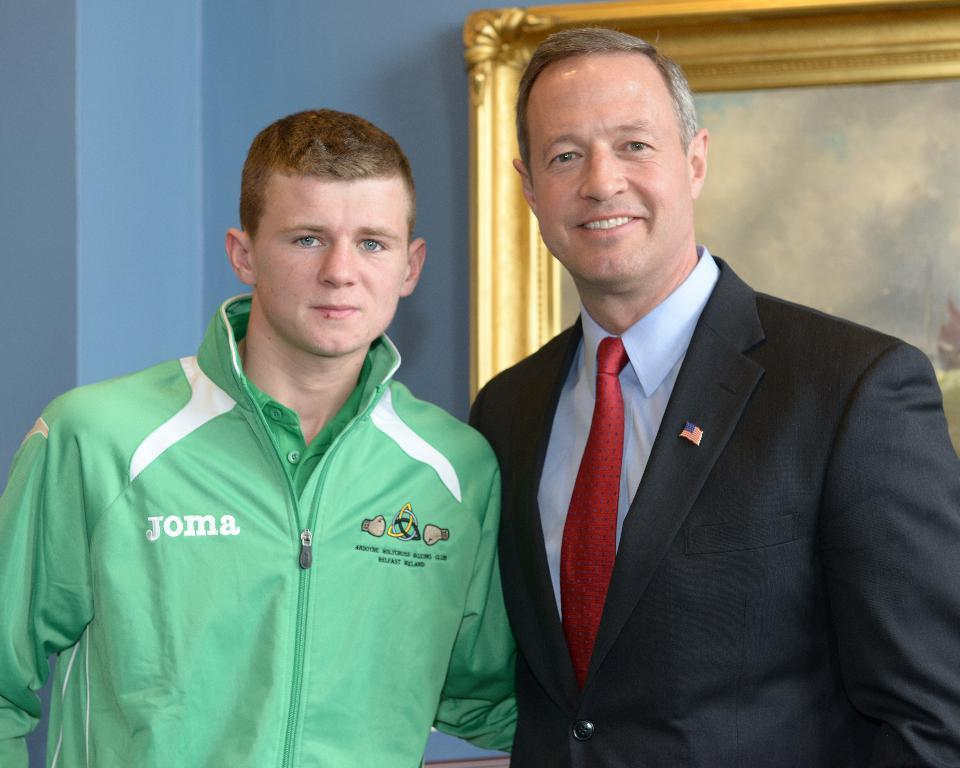<image>
Write a terse but informative summary of the picture. A guy in a green coat has the word Joma on the chest. 